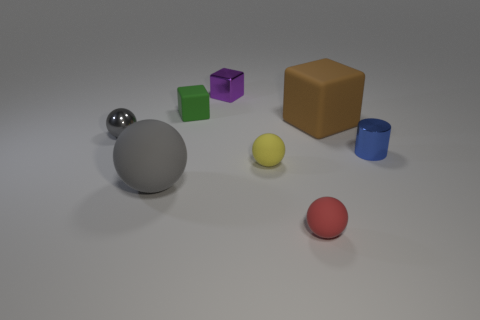What textures can be observed on the objects in the image? The image features objects with different textures: the balls appear to have a matte finish suggesting a rubbery texture, while the cubes and the cylinder present a smoother, more reflective surface which could indicate a metallic or plastic material. 